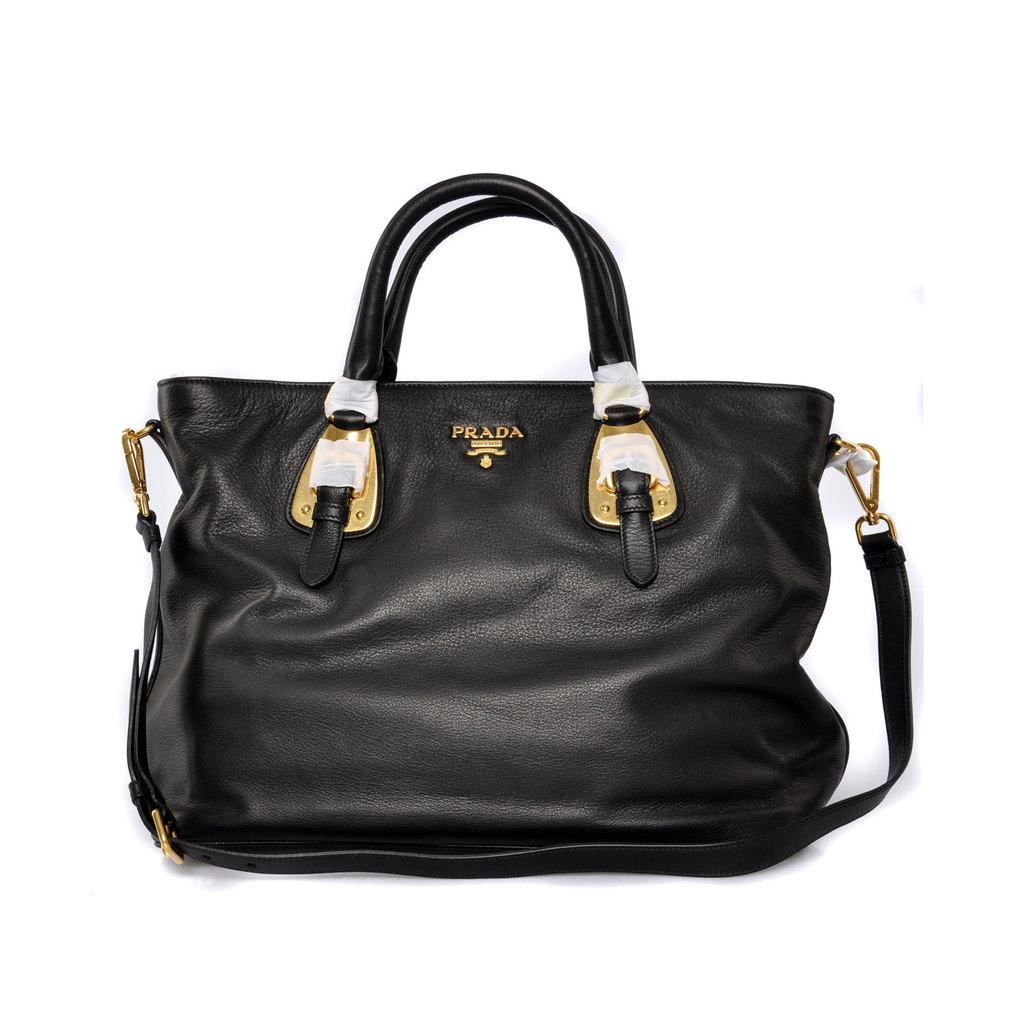What object can be seen in the image? There is a bag in the image. What is the color of the bag? The bag has a black color. Are there any specific features on the bag? Yes, the bag has a strip. Can you see a church in the image? No, there is no church present in the image. Are there any people kissing in the image? No, there are no people or any indication of a kiss in the image. 